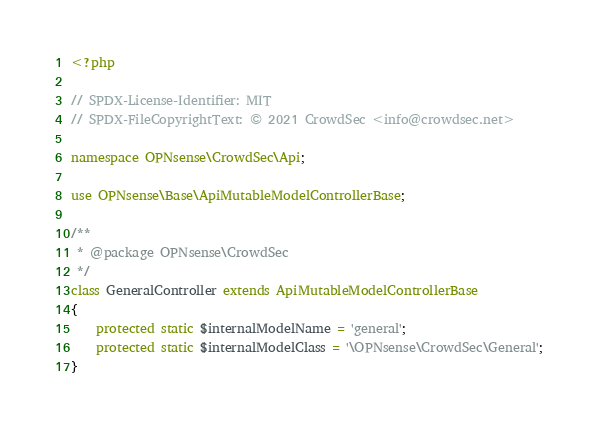Convert code to text. <code><loc_0><loc_0><loc_500><loc_500><_PHP_><?php

// SPDX-License-Identifier: MIT
// SPDX-FileCopyrightText: © 2021 CrowdSec <info@crowdsec.net>

namespace OPNsense\CrowdSec\Api;

use OPNsense\Base\ApiMutableModelControllerBase;

/**
 * @package OPNsense\CrowdSec
 */
class GeneralController extends ApiMutableModelControllerBase
{
    protected static $internalModelName = 'general';
    protected static $internalModelClass = '\OPNsense\CrowdSec\General';
}
</code> 